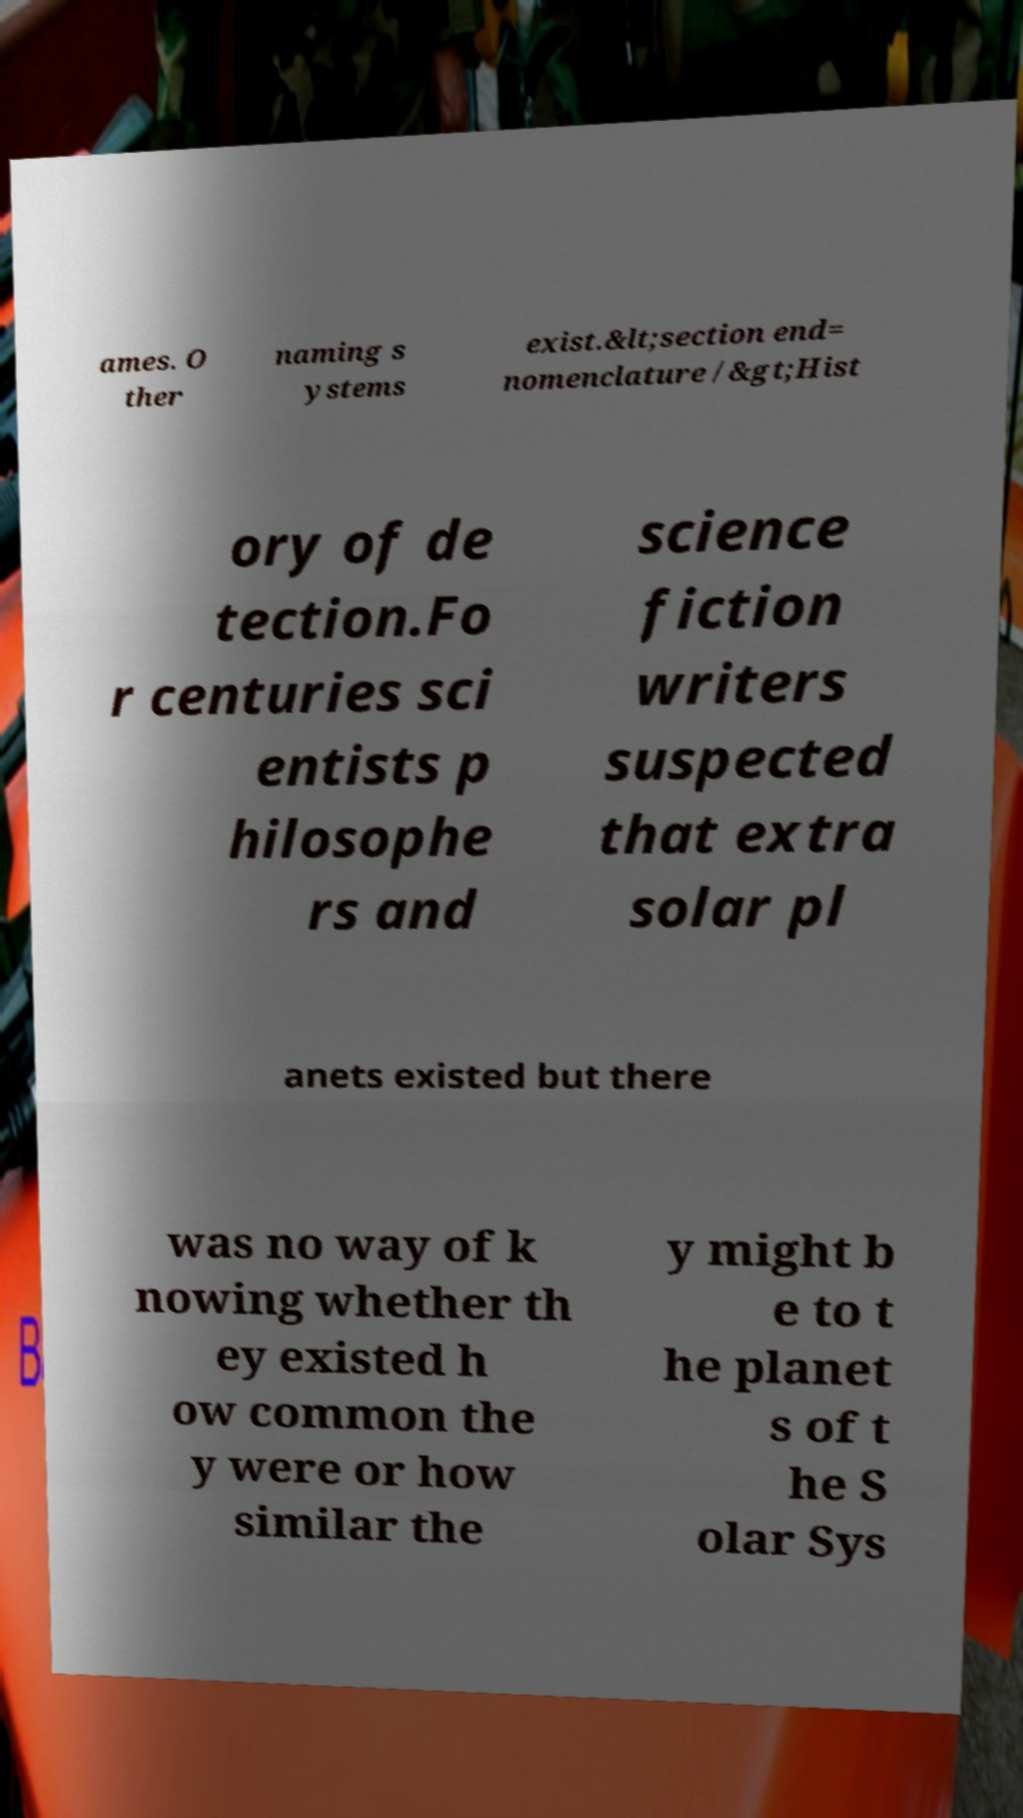There's text embedded in this image that I need extracted. Can you transcribe it verbatim? ames. O ther naming s ystems exist.&lt;section end= nomenclature /&gt;Hist ory of de tection.Fo r centuries sci entists p hilosophe rs and science fiction writers suspected that extra solar pl anets existed but there was no way of k nowing whether th ey existed h ow common the y were or how similar the y might b e to t he planet s of t he S olar Sys 